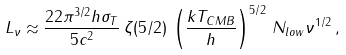<formula> <loc_0><loc_0><loc_500><loc_500>L _ { \nu } \approx \frac { 2 2 \pi ^ { 3 / 2 } h \sigma _ { T } } { 5 c ^ { 2 } } \, \zeta ( 5 / 2 ) \, \left ( \frac { k T _ { C M B } } { h } \right ) ^ { 5 / 2 } \, N _ { l o w } \nu ^ { 1 / 2 } \, ,</formula> 